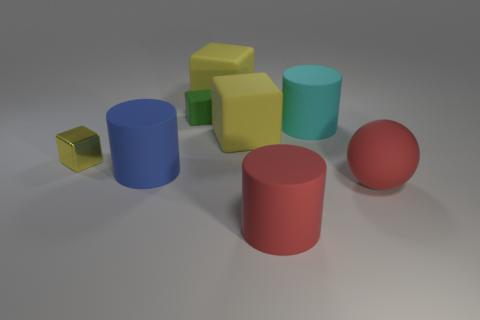Subtract all yellow spheres. How many yellow cubes are left? 3 Add 1 tiny green rubber objects. How many objects exist? 9 Subtract all balls. How many objects are left? 7 Subtract 0 blue cubes. How many objects are left? 8 Subtract all blue matte objects. Subtract all cyan matte things. How many objects are left? 6 Add 2 tiny matte objects. How many tiny matte objects are left? 3 Add 8 green objects. How many green objects exist? 9 